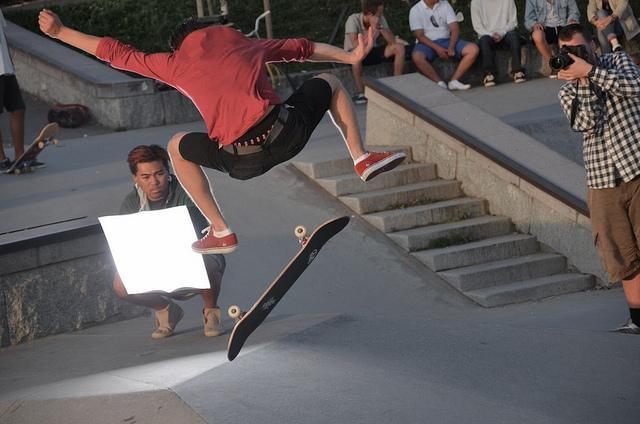How many people are there?
Give a very brief answer. 8. How many feet of the elephant are on the ground?
Give a very brief answer. 0. 